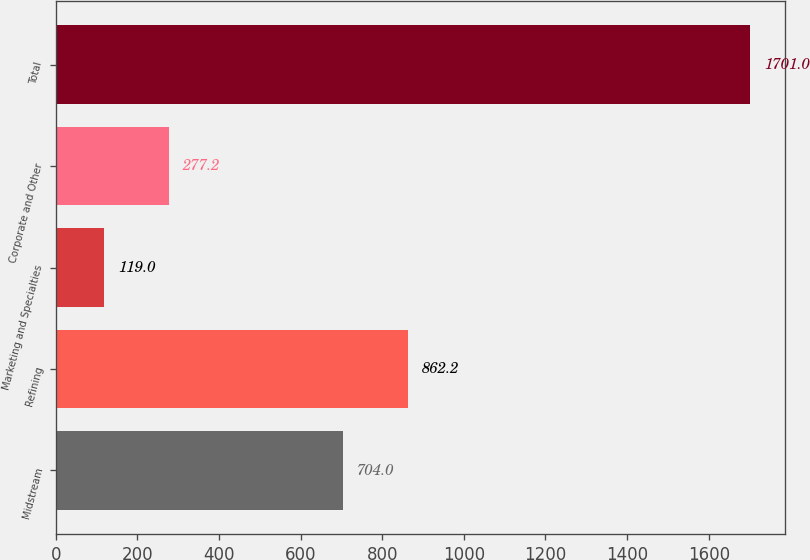Convert chart. <chart><loc_0><loc_0><loc_500><loc_500><bar_chart><fcel>Midstream<fcel>Refining<fcel>Marketing and Specialties<fcel>Corporate and Other<fcel>Total<nl><fcel>704<fcel>862.2<fcel>119<fcel>277.2<fcel>1701<nl></chart> 